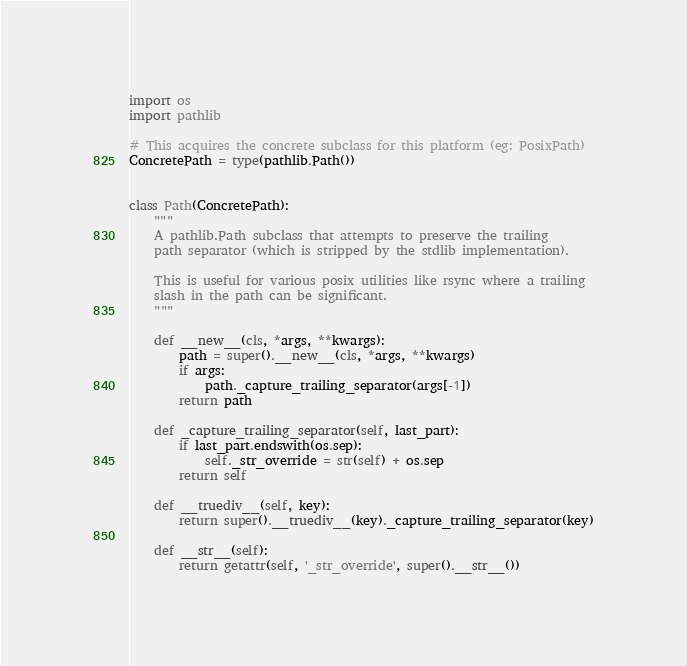<code> <loc_0><loc_0><loc_500><loc_500><_Python_>import os
import pathlib

# This acquires the concrete subclass for this platform (eg: PosixPath)
ConcretePath = type(pathlib.Path())


class Path(ConcretePath):
    """
    A pathlib.Path subclass that attempts to preserve the trailing
    path separator (which is stripped by the stdlib implementation).

    This is useful for various posix utilities like rsync where a trailing
    slash in the path can be significant.
    """

    def __new__(cls, *args, **kwargs):
        path = super().__new__(cls, *args, **kwargs)
        if args:
            path._capture_trailing_separator(args[-1])
        return path

    def _capture_trailing_separator(self, last_part):
        if last_part.endswith(os.sep):
            self._str_override = str(self) + os.sep
        return self

    def __truediv__(self, key):
        return super().__truediv__(key)._capture_trailing_separator(key)

    def __str__(self):
        return getattr(self, '_str_override', super().__str__())
</code> 